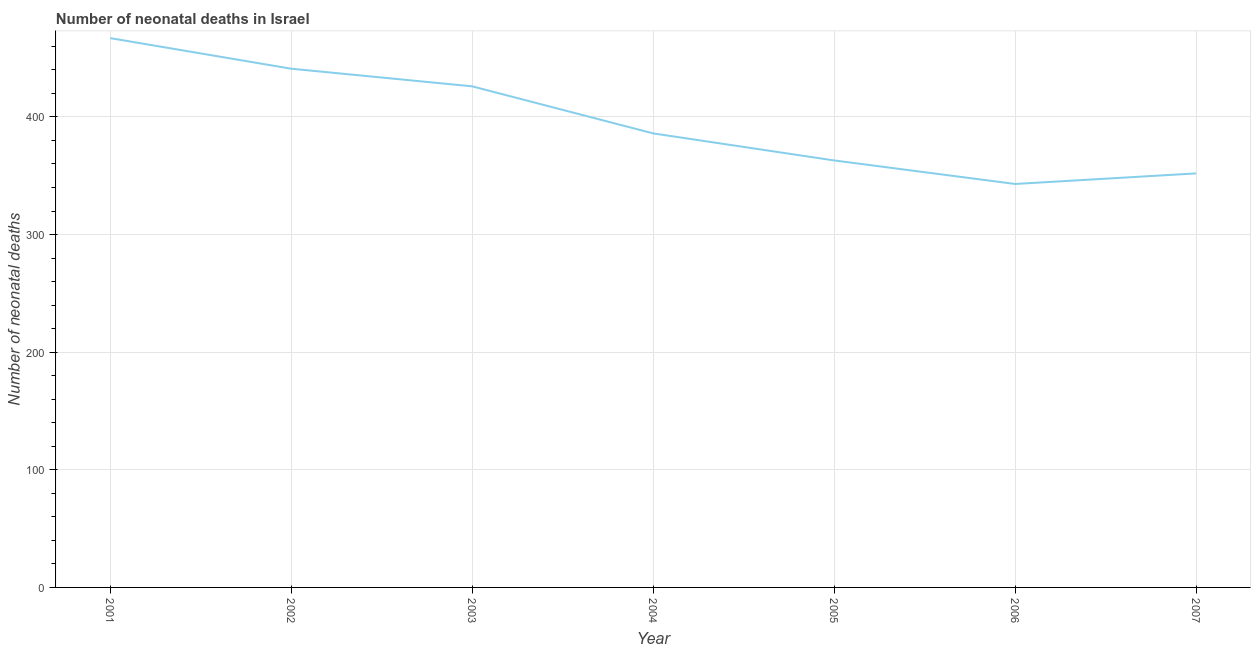What is the number of neonatal deaths in 2006?
Your answer should be compact. 343. Across all years, what is the maximum number of neonatal deaths?
Offer a very short reply. 467. Across all years, what is the minimum number of neonatal deaths?
Ensure brevity in your answer.  343. In which year was the number of neonatal deaths maximum?
Offer a very short reply. 2001. What is the sum of the number of neonatal deaths?
Ensure brevity in your answer.  2778. What is the difference between the number of neonatal deaths in 2002 and 2007?
Provide a short and direct response. 89. What is the average number of neonatal deaths per year?
Your answer should be compact. 396.86. What is the median number of neonatal deaths?
Your response must be concise. 386. Do a majority of the years between 2006 and 2007 (inclusive) have number of neonatal deaths greater than 300 ?
Keep it short and to the point. Yes. What is the ratio of the number of neonatal deaths in 2001 to that in 2005?
Give a very brief answer. 1.29. Is the number of neonatal deaths in 2002 less than that in 2005?
Offer a very short reply. No. Is the difference between the number of neonatal deaths in 2001 and 2004 greater than the difference between any two years?
Keep it short and to the point. No. What is the difference between the highest and the second highest number of neonatal deaths?
Give a very brief answer. 26. What is the difference between the highest and the lowest number of neonatal deaths?
Your answer should be very brief. 124. In how many years, is the number of neonatal deaths greater than the average number of neonatal deaths taken over all years?
Your response must be concise. 3. Does the number of neonatal deaths monotonically increase over the years?
Your response must be concise. No. How many lines are there?
Your response must be concise. 1. How many years are there in the graph?
Provide a succinct answer. 7. Are the values on the major ticks of Y-axis written in scientific E-notation?
Your answer should be very brief. No. Does the graph contain any zero values?
Offer a terse response. No. Does the graph contain grids?
Give a very brief answer. Yes. What is the title of the graph?
Provide a short and direct response. Number of neonatal deaths in Israel. What is the label or title of the Y-axis?
Your answer should be very brief. Number of neonatal deaths. What is the Number of neonatal deaths of 2001?
Provide a succinct answer. 467. What is the Number of neonatal deaths of 2002?
Provide a succinct answer. 441. What is the Number of neonatal deaths of 2003?
Provide a succinct answer. 426. What is the Number of neonatal deaths in 2004?
Give a very brief answer. 386. What is the Number of neonatal deaths of 2005?
Your answer should be compact. 363. What is the Number of neonatal deaths of 2006?
Offer a very short reply. 343. What is the Number of neonatal deaths in 2007?
Ensure brevity in your answer.  352. What is the difference between the Number of neonatal deaths in 2001 and 2003?
Your response must be concise. 41. What is the difference between the Number of neonatal deaths in 2001 and 2004?
Offer a very short reply. 81. What is the difference between the Number of neonatal deaths in 2001 and 2005?
Make the answer very short. 104. What is the difference between the Number of neonatal deaths in 2001 and 2006?
Your response must be concise. 124. What is the difference between the Number of neonatal deaths in 2001 and 2007?
Keep it short and to the point. 115. What is the difference between the Number of neonatal deaths in 2002 and 2003?
Offer a terse response. 15. What is the difference between the Number of neonatal deaths in 2002 and 2005?
Keep it short and to the point. 78. What is the difference between the Number of neonatal deaths in 2002 and 2007?
Provide a succinct answer. 89. What is the difference between the Number of neonatal deaths in 2003 and 2005?
Offer a terse response. 63. What is the difference between the Number of neonatal deaths in 2003 and 2006?
Make the answer very short. 83. What is the difference between the Number of neonatal deaths in 2004 and 2006?
Offer a terse response. 43. What is the difference between the Number of neonatal deaths in 2005 and 2006?
Make the answer very short. 20. What is the difference between the Number of neonatal deaths in 2005 and 2007?
Your answer should be compact. 11. What is the ratio of the Number of neonatal deaths in 2001 to that in 2002?
Keep it short and to the point. 1.06. What is the ratio of the Number of neonatal deaths in 2001 to that in 2003?
Provide a short and direct response. 1.1. What is the ratio of the Number of neonatal deaths in 2001 to that in 2004?
Provide a short and direct response. 1.21. What is the ratio of the Number of neonatal deaths in 2001 to that in 2005?
Your answer should be very brief. 1.29. What is the ratio of the Number of neonatal deaths in 2001 to that in 2006?
Offer a terse response. 1.36. What is the ratio of the Number of neonatal deaths in 2001 to that in 2007?
Your answer should be compact. 1.33. What is the ratio of the Number of neonatal deaths in 2002 to that in 2003?
Your response must be concise. 1.03. What is the ratio of the Number of neonatal deaths in 2002 to that in 2004?
Offer a very short reply. 1.14. What is the ratio of the Number of neonatal deaths in 2002 to that in 2005?
Provide a succinct answer. 1.22. What is the ratio of the Number of neonatal deaths in 2002 to that in 2006?
Keep it short and to the point. 1.29. What is the ratio of the Number of neonatal deaths in 2002 to that in 2007?
Offer a very short reply. 1.25. What is the ratio of the Number of neonatal deaths in 2003 to that in 2004?
Provide a succinct answer. 1.1. What is the ratio of the Number of neonatal deaths in 2003 to that in 2005?
Provide a short and direct response. 1.17. What is the ratio of the Number of neonatal deaths in 2003 to that in 2006?
Provide a short and direct response. 1.24. What is the ratio of the Number of neonatal deaths in 2003 to that in 2007?
Make the answer very short. 1.21. What is the ratio of the Number of neonatal deaths in 2004 to that in 2005?
Give a very brief answer. 1.06. What is the ratio of the Number of neonatal deaths in 2004 to that in 2006?
Keep it short and to the point. 1.12. What is the ratio of the Number of neonatal deaths in 2004 to that in 2007?
Your answer should be compact. 1.1. What is the ratio of the Number of neonatal deaths in 2005 to that in 2006?
Your answer should be very brief. 1.06. What is the ratio of the Number of neonatal deaths in 2005 to that in 2007?
Your answer should be very brief. 1.03. What is the ratio of the Number of neonatal deaths in 2006 to that in 2007?
Make the answer very short. 0.97. 